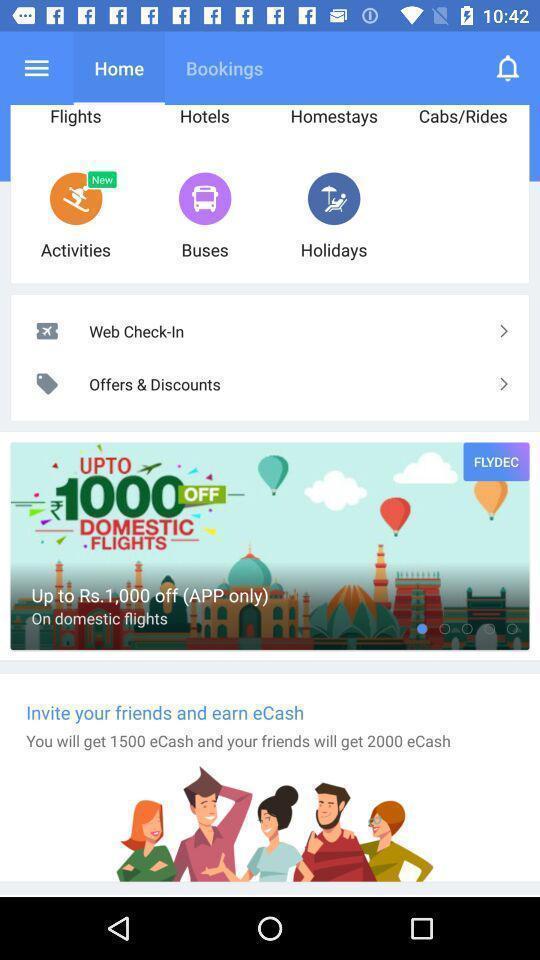Please provide a description for this image. Page displaying different options on a travel app. 